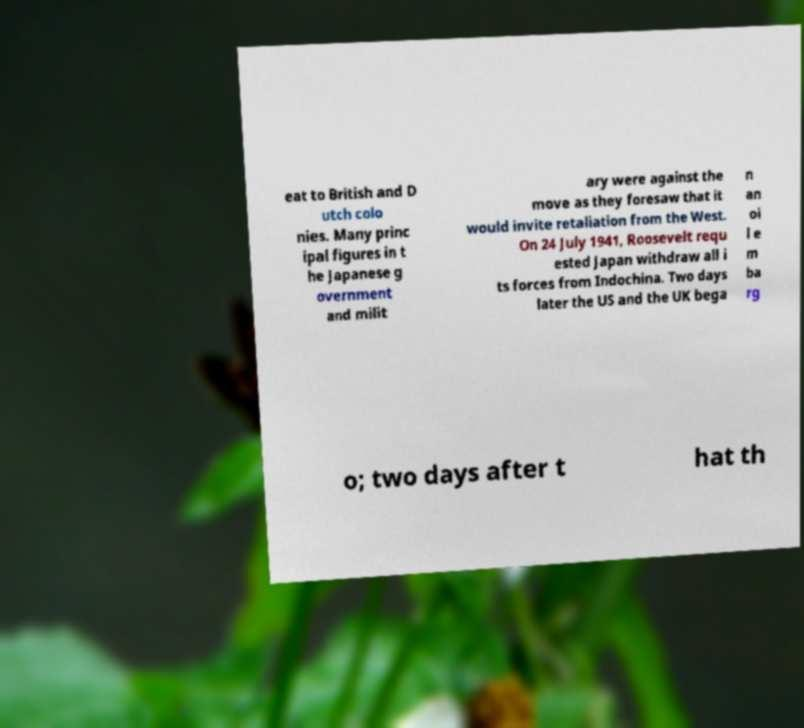There's text embedded in this image that I need extracted. Can you transcribe it verbatim? eat to British and D utch colo nies. Many princ ipal figures in t he Japanese g overnment and milit ary were against the move as they foresaw that it would invite retaliation from the West. On 24 July 1941, Roosevelt requ ested Japan withdraw all i ts forces from Indochina. Two days later the US and the UK bega n an oi l e m ba rg o; two days after t hat th 